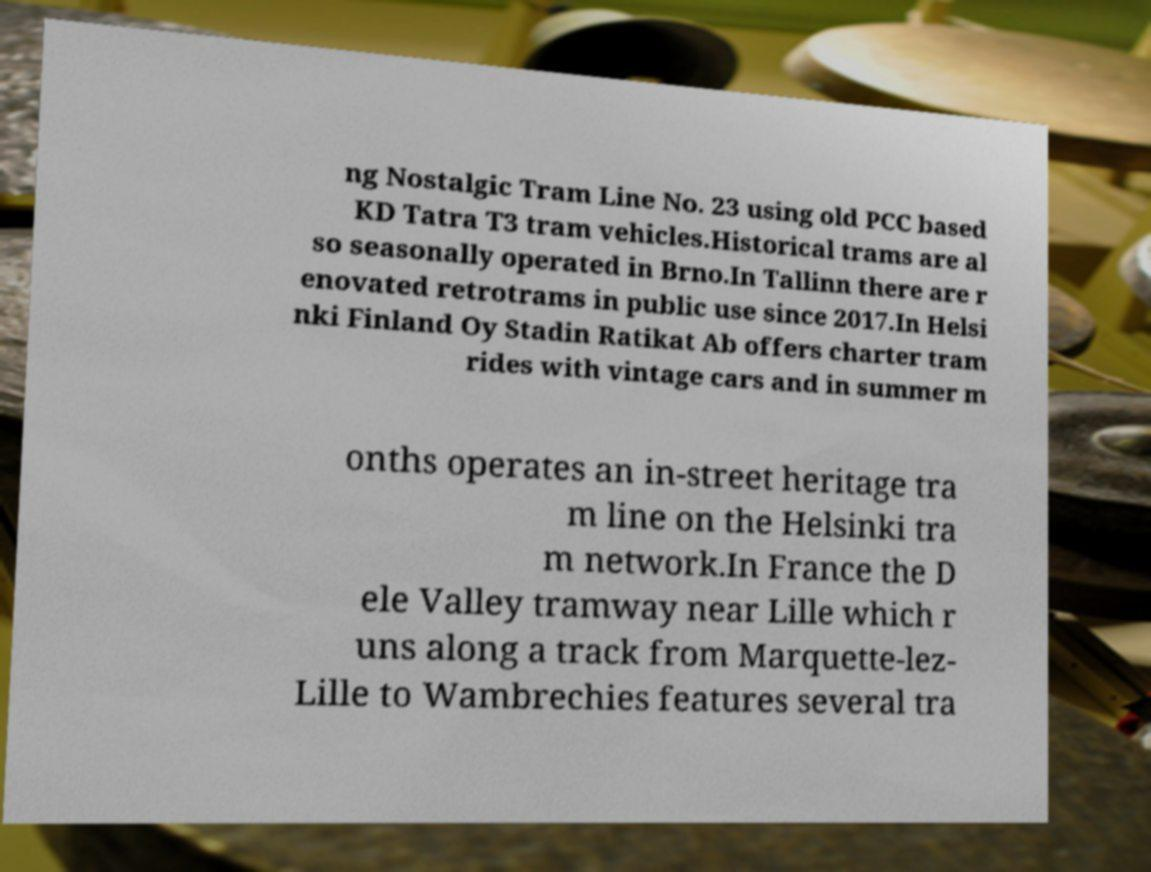Could you extract and type out the text from this image? ng Nostalgic Tram Line No. 23 using old PCC based KD Tatra T3 tram vehicles.Historical trams are al so seasonally operated in Brno.In Tallinn there are r enovated retrotrams in public use since 2017.In Helsi nki Finland Oy Stadin Ratikat Ab offers charter tram rides with vintage cars and in summer m onths operates an in-street heritage tra m line on the Helsinki tra m network.In France the D ele Valley tramway near Lille which r uns along a track from Marquette-lez- Lille to Wambrechies features several tra 